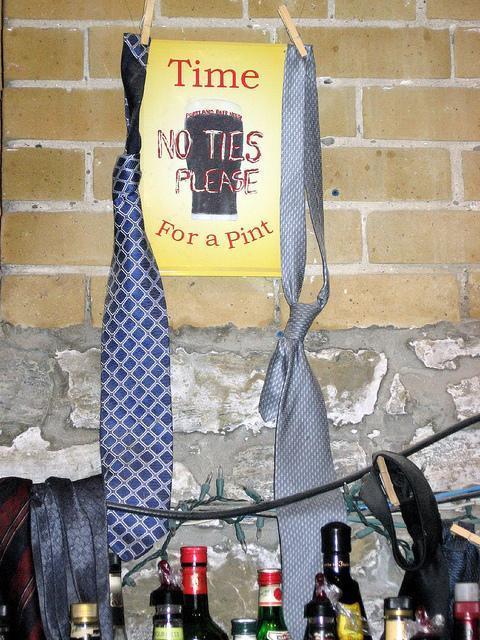How many ties are there?
Give a very brief answer. 7. How many bottles are visible?
Give a very brief answer. 2. 